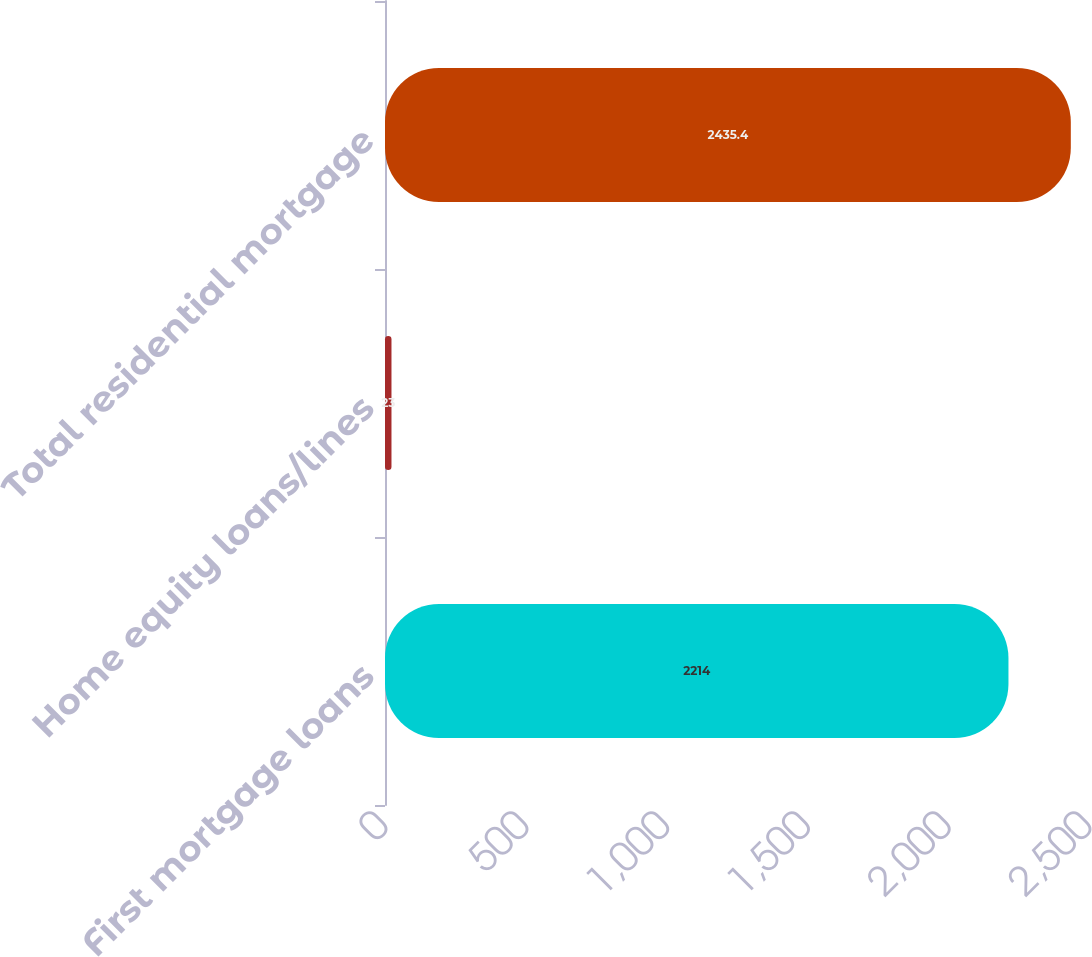<chart> <loc_0><loc_0><loc_500><loc_500><bar_chart><fcel>First mortgage loans<fcel>Home equity loans/lines<fcel>Total residential mortgage<nl><fcel>2214<fcel>23<fcel>2435.4<nl></chart> 